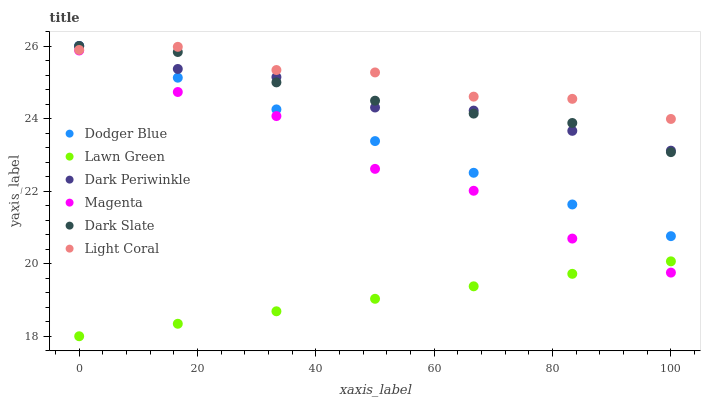Does Lawn Green have the minimum area under the curve?
Answer yes or no. Yes. Does Light Coral have the maximum area under the curve?
Answer yes or no. Yes. Does Dark Slate have the minimum area under the curve?
Answer yes or no. No. Does Dark Slate have the maximum area under the curve?
Answer yes or no. No. Is Dodger Blue the smoothest?
Answer yes or no. Yes. Is Magenta the roughest?
Answer yes or no. Yes. Is Light Coral the smoothest?
Answer yes or no. No. Is Light Coral the roughest?
Answer yes or no. No. Does Lawn Green have the lowest value?
Answer yes or no. Yes. Does Dark Slate have the lowest value?
Answer yes or no. No. Does Dark Periwinkle have the highest value?
Answer yes or no. Yes. Does Light Coral have the highest value?
Answer yes or no. No. Is Lawn Green less than Dark Slate?
Answer yes or no. Yes. Is Light Coral greater than Lawn Green?
Answer yes or no. Yes. Does Dark Periwinkle intersect Dodger Blue?
Answer yes or no. Yes. Is Dark Periwinkle less than Dodger Blue?
Answer yes or no. No. Is Dark Periwinkle greater than Dodger Blue?
Answer yes or no. No. Does Lawn Green intersect Dark Slate?
Answer yes or no. No. 